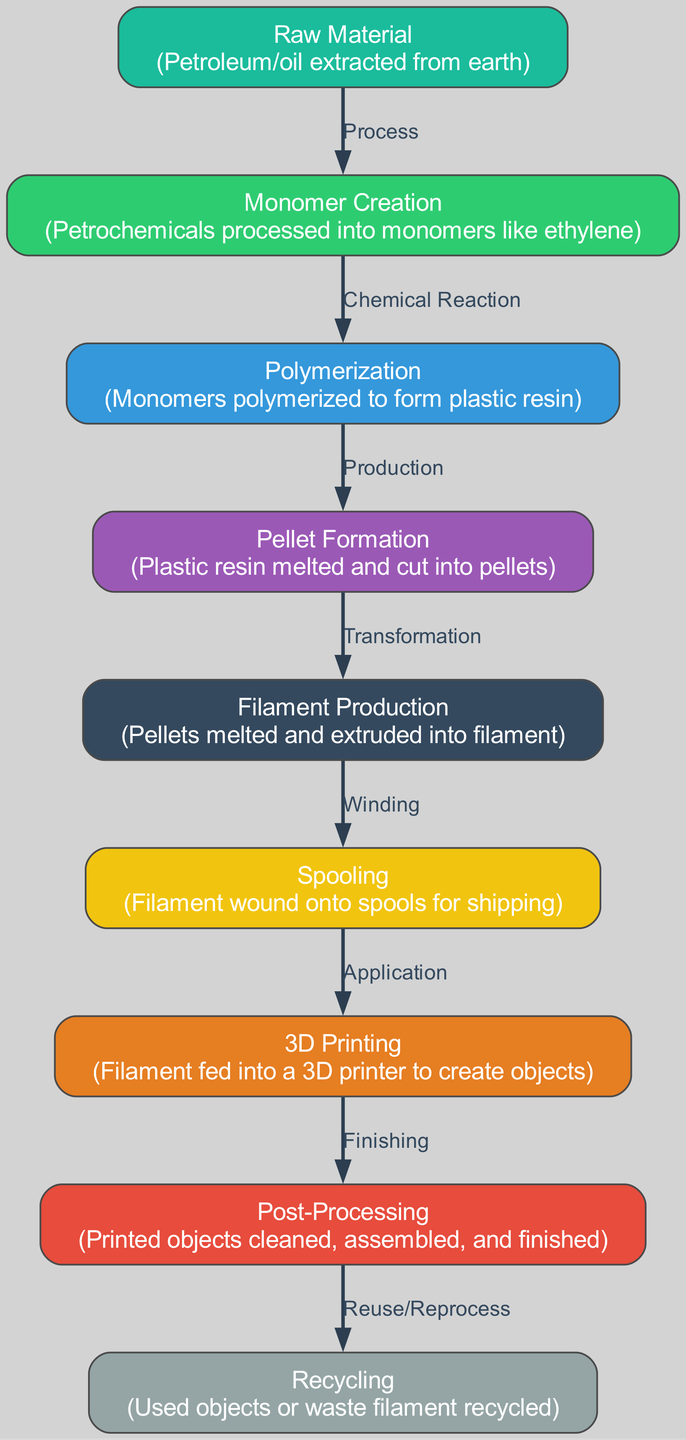What is the first step in the lifecycle of plastic filament? The first step is labeled "Raw Material," which involves the extraction of petroleum or oil from the earth.
Answer: Raw Material How many nodes are in the diagram? By counting all the individual labeled stages shown as nodes, we can determine there are nine nodes that represent different stages in the lifecycle.
Answer: 9 What is the final stage after post-processing? The diagram indicates that the final stage is "Recycling," which refers to the process of reusing or reprocessing materials after they have been used.
Answer: Recycling Which stage processes Petrochemicals into monomers? The stage that handles this processing is labeled "Monomer Creation," where petrochemicals are transformed into smaller molecules called monomers.
Answer: Monomer Creation What type of connection exists between polymerization and pellet formation? The connection type indicated in the diagram is "Production," which suggests that pellet formation follows polymerization as a result of producing plastic resin.
Answer: Production During which step is filament wound onto spools? The step where filament is wound onto spools is labeled "Spooling," which is necessary for the easy handling and shipping of filament materials.
Answer: Spooling What is the main action occurring during the filament production stage? During the filament production stage, the main action is "melted and extruded," which indicates that plastic pellets are melted and then formed into filament.
Answer: Melted and extruded What follows the 3D printing step in the lifecycle? Following the 3D printing step, the process goes to "Post-Processing," which involves cleaning, assembling, and finishing the printed objects.
Answer: Post-Processing What transformation occurs before filament production? The transformation that occurs before filament production is described as "Transformation," where pellets are converted to filament.
Answer: Transformation 